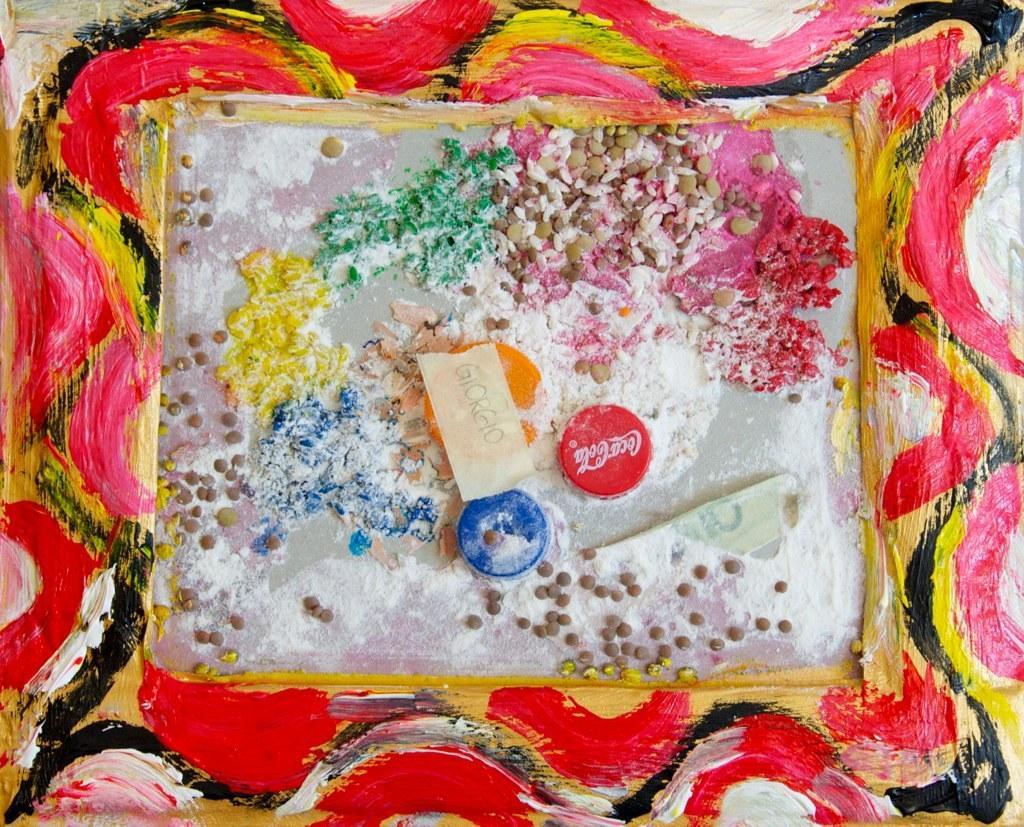Describe this image in one or two sentences. In this image I can see a frame which is painted. There are bottle caps and other items in the center. 